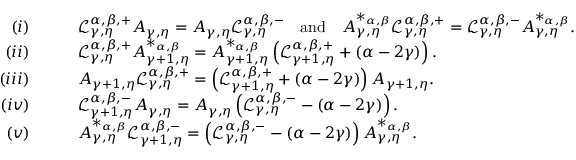<formula> <loc_0><loc_0><loc_500><loc_500>\begin{array} { r l } { ( i ) } & { \quad \mathcal { L } _ { \gamma , \eta } ^ { \alpha , \beta , + } A _ { \gamma , \eta } = A _ { \gamma , \eta } \mathcal { L } _ { \gamma , \eta } ^ { \alpha , \beta , - } \quad a n d \quad A _ { \gamma , \eta } ^ { * _ { \alpha , \beta } } \mathcal { L } _ { \gamma , \eta } ^ { \alpha , \beta , + } = \mathcal { L } _ { \gamma , \eta } ^ { \alpha , \beta , - } A _ { \gamma , \eta } ^ { * _ { \alpha , \beta } } . } \\ { ( i i ) } & { \quad \mathcal { L } _ { \gamma , \eta } ^ { \alpha , \beta , + } A _ { \gamma + 1 , \eta } ^ { * _ { \alpha , \beta } } = A _ { \gamma + 1 , \eta } ^ { * _ { \alpha , \beta } } \left ( \mathcal { L } _ { \gamma + 1 , \eta } ^ { \alpha , \beta , + } + ( \alpha - 2 \gamma ) \right ) . } \\ { ( i i i ) } & { \quad A _ { \gamma + 1 , \eta } \mathcal { L } _ { \gamma , \eta } ^ { \alpha , \beta , + } = \left ( \mathcal { L } _ { \gamma + 1 , \eta } ^ { \alpha , \beta , + } + ( \alpha - 2 \gamma ) \right ) A _ { \gamma + 1 , \eta } . } \\ { ( i v ) } & { \quad \mathcal { L } _ { \gamma + 1 , \eta } ^ { \alpha , \beta , - } A _ { \gamma , \eta } = A _ { \gamma , \eta } \left ( \mathcal { L } _ { \gamma , \eta } ^ { \alpha , \beta , - } - ( \alpha - 2 \gamma ) \right ) . } \\ { ( v ) } & { \quad A _ { \gamma , \eta } ^ { * _ { \alpha , \beta } } \mathcal { L } _ { \gamma + 1 , \eta } ^ { \alpha , \beta , - } = \left ( \mathcal { L } _ { \gamma , \eta } ^ { \alpha , \beta , - } - ( \alpha - 2 \gamma ) \right ) A _ { \gamma , \eta } ^ { * _ { \alpha , \beta } } . } \end{array}</formula> 